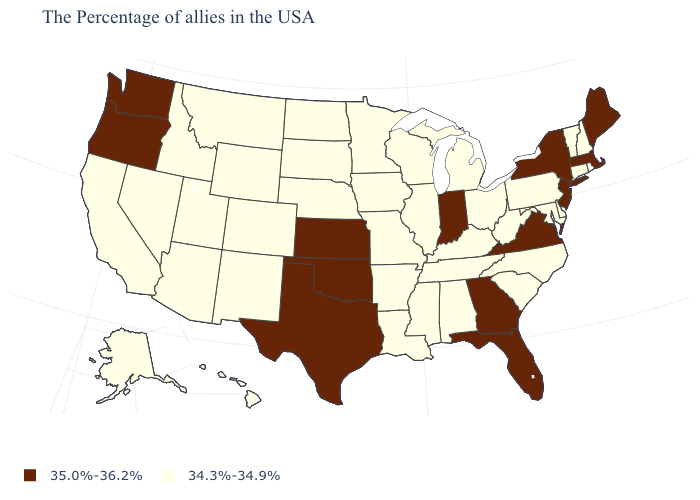Does Florida have a higher value than New York?
Answer briefly. No. Does the first symbol in the legend represent the smallest category?
Quick response, please. No. Which states have the lowest value in the USA?
Short answer required. Rhode Island, New Hampshire, Vermont, Connecticut, Delaware, Maryland, Pennsylvania, North Carolina, South Carolina, West Virginia, Ohio, Michigan, Kentucky, Alabama, Tennessee, Wisconsin, Illinois, Mississippi, Louisiana, Missouri, Arkansas, Minnesota, Iowa, Nebraska, South Dakota, North Dakota, Wyoming, Colorado, New Mexico, Utah, Montana, Arizona, Idaho, Nevada, California, Alaska, Hawaii. Is the legend a continuous bar?
Write a very short answer. No. Which states hav the highest value in the West?
Concise answer only. Washington, Oregon. Which states hav the highest value in the Northeast?
Concise answer only. Maine, Massachusetts, New York, New Jersey. Does New Mexico have a higher value than Georgia?
Quick response, please. No. Does Oregon have the lowest value in the USA?
Concise answer only. No. Which states have the highest value in the USA?
Answer briefly. Maine, Massachusetts, New York, New Jersey, Virginia, Florida, Georgia, Indiana, Kansas, Oklahoma, Texas, Washington, Oregon. Does Montana have the same value as North Carolina?
Short answer required. Yes. Name the states that have a value in the range 34.3%-34.9%?
Answer briefly. Rhode Island, New Hampshire, Vermont, Connecticut, Delaware, Maryland, Pennsylvania, North Carolina, South Carolina, West Virginia, Ohio, Michigan, Kentucky, Alabama, Tennessee, Wisconsin, Illinois, Mississippi, Louisiana, Missouri, Arkansas, Minnesota, Iowa, Nebraska, South Dakota, North Dakota, Wyoming, Colorado, New Mexico, Utah, Montana, Arizona, Idaho, Nevada, California, Alaska, Hawaii. What is the value of Oklahoma?
Keep it brief. 35.0%-36.2%. What is the value of North Dakota?
Quick response, please. 34.3%-34.9%. Name the states that have a value in the range 35.0%-36.2%?
Give a very brief answer. Maine, Massachusetts, New York, New Jersey, Virginia, Florida, Georgia, Indiana, Kansas, Oklahoma, Texas, Washington, Oregon. What is the value of Indiana?
Concise answer only. 35.0%-36.2%. 